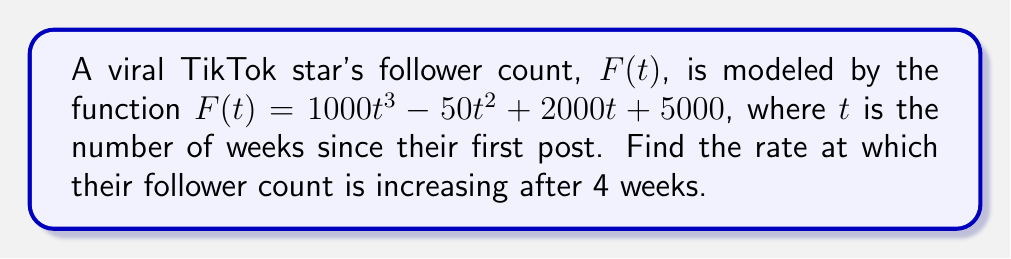Can you solve this math problem? To find the rate at which the follower count is increasing, we need to find the derivative of the function $F(t)$ and then evaluate it at $t = 4$.

Step 1: Find the derivative of $F(t)$.
$$F'(t) = \frac{d}{dt}(1000t^3 - 50t^2 + 2000t + 5000)$$
$$F'(t) = 3000t^2 - 100t + 2000$$

Step 2: Evaluate $F'(t)$ at $t = 4$.
$$F'(4) = 3000(4)^2 - 100(4) + 2000$$
$$F'(4) = 3000(16) - 400 + 2000$$
$$F'(4) = 48000 - 400 + 2000$$
$$F'(4) = 49600$$

The rate of change at $t = 4$ is 49,600 followers per week.
Answer: 49,600 followers/week 